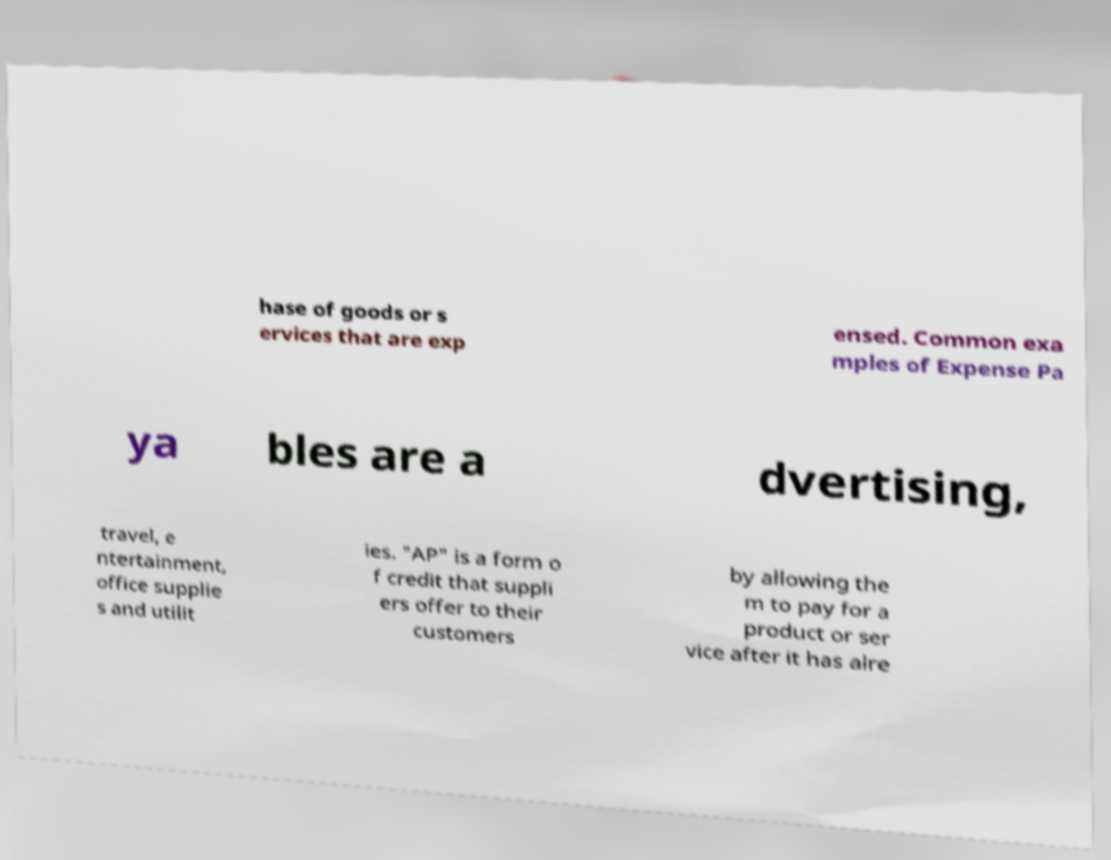There's text embedded in this image that I need extracted. Can you transcribe it verbatim? hase of goods or s ervices that are exp ensed. Common exa mples of Expense Pa ya bles are a dvertising, travel, e ntertainment, office supplie s and utilit ies. "AP" is a form o f credit that suppli ers offer to their customers by allowing the m to pay for a product or ser vice after it has alre 